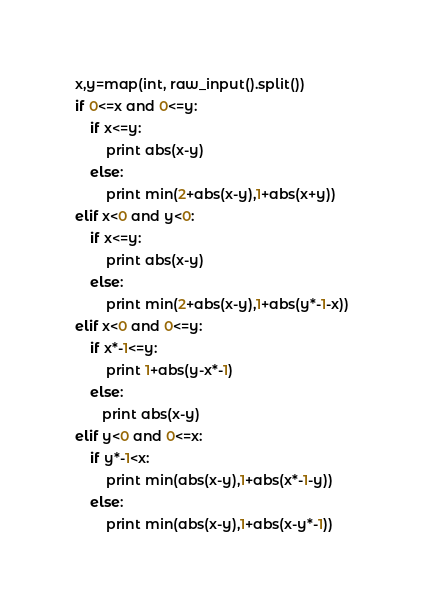<code> <loc_0><loc_0><loc_500><loc_500><_Python_>x,y=map(int, raw_input().split())
if 0<=x and 0<=y:
    if x<=y:
        print abs(x-y)
    else:
        print min(2+abs(x-y),1+abs(x+y))
elif x<0 and y<0:
    if x<=y:
        print abs(x-y)
    else:
        print min(2+abs(x-y),1+abs(y*-1-x))
elif x<0 and 0<=y:
    if x*-1<=y:
        print 1+abs(y-x*-1)
    else:
       print abs(x-y)
elif y<0 and 0<=x:
    if y*-1<x:
        print min(abs(x-y),1+abs(x*-1-y))
    else:
        print min(abs(x-y),1+abs(x-y*-1))
</code> 